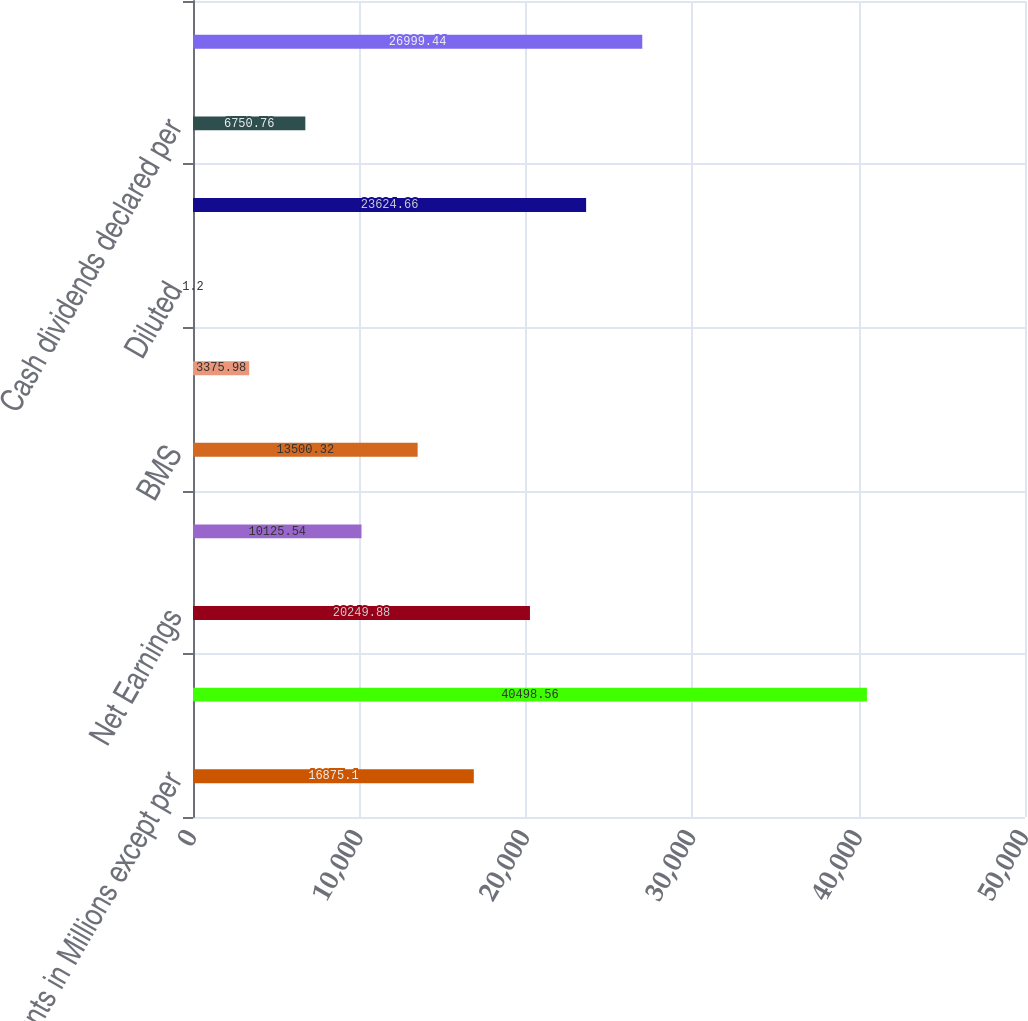<chart> <loc_0><loc_0><loc_500><loc_500><bar_chart><fcel>Amounts in Millions except per<fcel>Total Revenues<fcel>Net Earnings<fcel>Noncontrolling Interest<fcel>BMS<fcel>Basic<fcel>Diluted<fcel>Cash dividends paid on BMS<fcel>Cash dividends declared per<fcel>Cash and cash equivalents<nl><fcel>16875.1<fcel>40498.6<fcel>20249.9<fcel>10125.5<fcel>13500.3<fcel>3375.98<fcel>1.2<fcel>23624.7<fcel>6750.76<fcel>26999.4<nl></chart> 